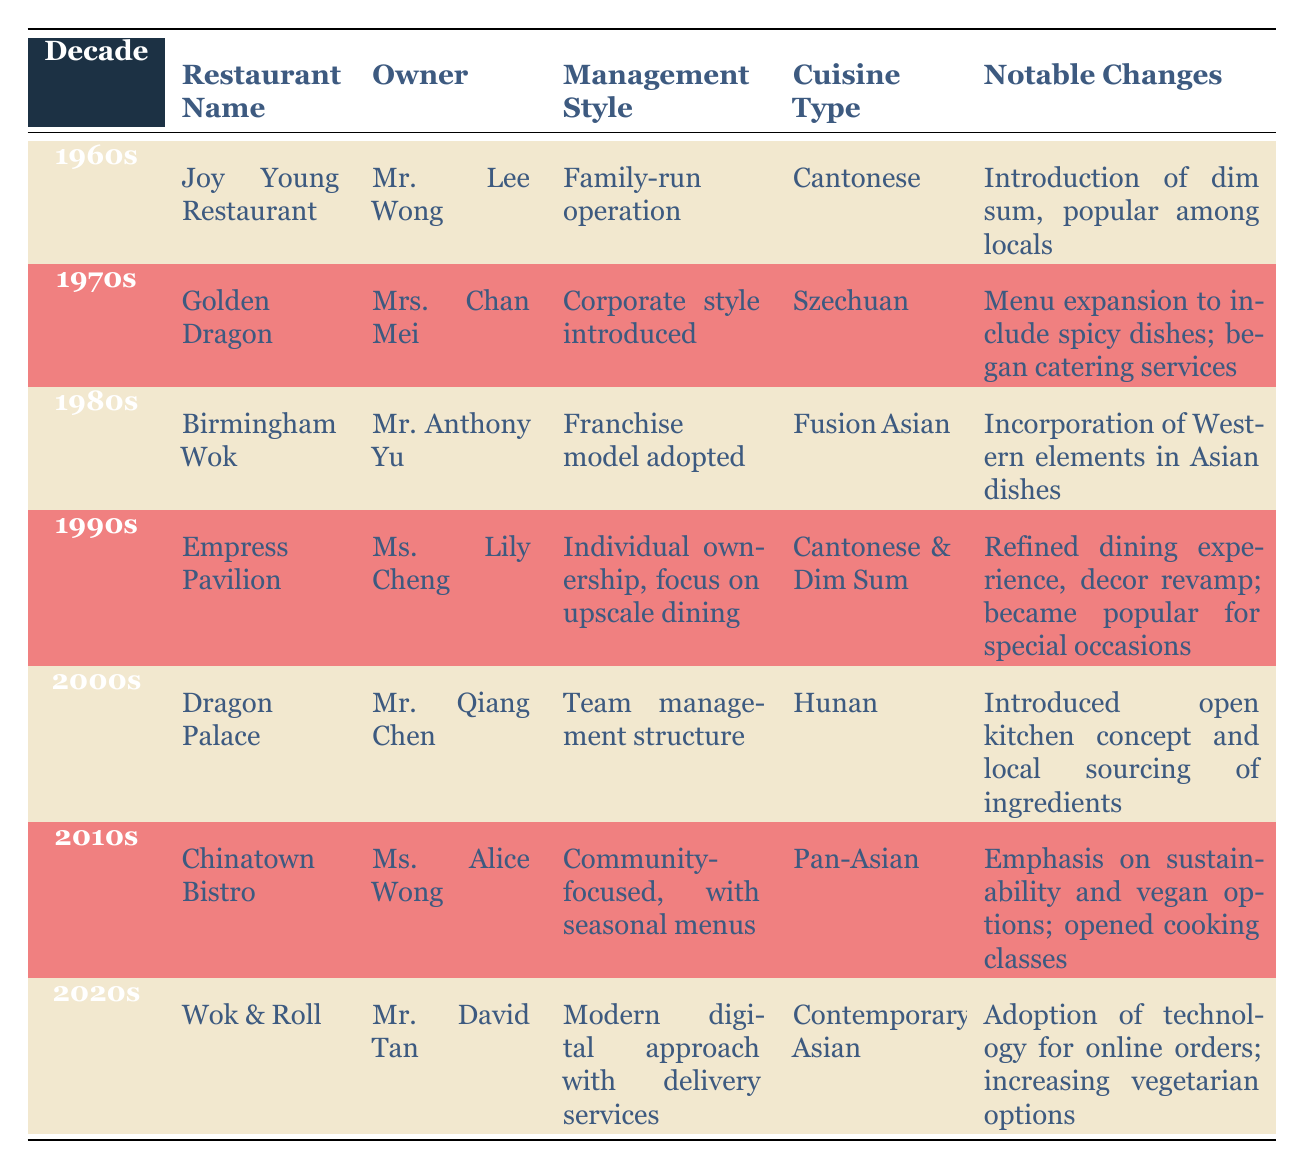What was the restaurant name in the 1970s? By looking at the table, in the row for the 1970s, the restaurant name listed is "Golden Dragon."
Answer: Golden Dragon Who owned the Joy Young Restaurant? The table specifies that the owner of Joy Young Restaurant in the 1960s was Mr. Lee Wong.
Answer: Mr. Lee Wong What cuisine type was served at the Empress Pavilion? From the table, the cuisine type for Empress Pavilion is listed as "Cantonese & Dim Sum."
Answer: Cantonese & Dim Sum Was the management style of Wok & Roll a traditional approach? The table states that Wok & Roll's management style was a "Modern digital approach with delivery services," indicating it is not a traditional approach.
Answer: No Which restaurant introduced an open kitchen concept in the 2000s? The table shows that Dragon Palace, owned by Mr. Qiang Chen, was the restaurant that introduced the open kitchen concept during the 2000s.
Answer: Dragon Palace In how many decades did the ownership change hands? By reviewing the table, we see the owners from each decade: Mr. Lee Wong, Mrs. Chan Mei, Mr. Anthony Yu, Ms. Lily Cheng, Mr. Qiang Chen, Ms. Alice Wong, and Mr. David Tan—one per decade—indicating that there was a change in ownership across all seven decades. Therefore, the ownership changed hands in six instances.
Answer: 6 What notable change occurred at Chinatown Bistro in the 2010s? Referring to the table, Chinatown Bistro's notable changes included an emphasis on sustainability and vegan options, as well as the opening of cooking classes.
Answer: Emphasis on sustainability and vegan options; opened cooking classes Did any restaurant during the 1960s offer Szechuan cuisine? Looking at the table, in the 1960s, the only restaurant listed is Joy Young Restaurant, which served Cantonese cuisine, not Szechuan cuisine.
Answer: No Which decade saw the expansion of a menu to include spicy dishes? The table indicates that the menu expansion to include spicy dishes occurred in the 1970s at the Golden Dragon restaurant.
Answer: 1970s 